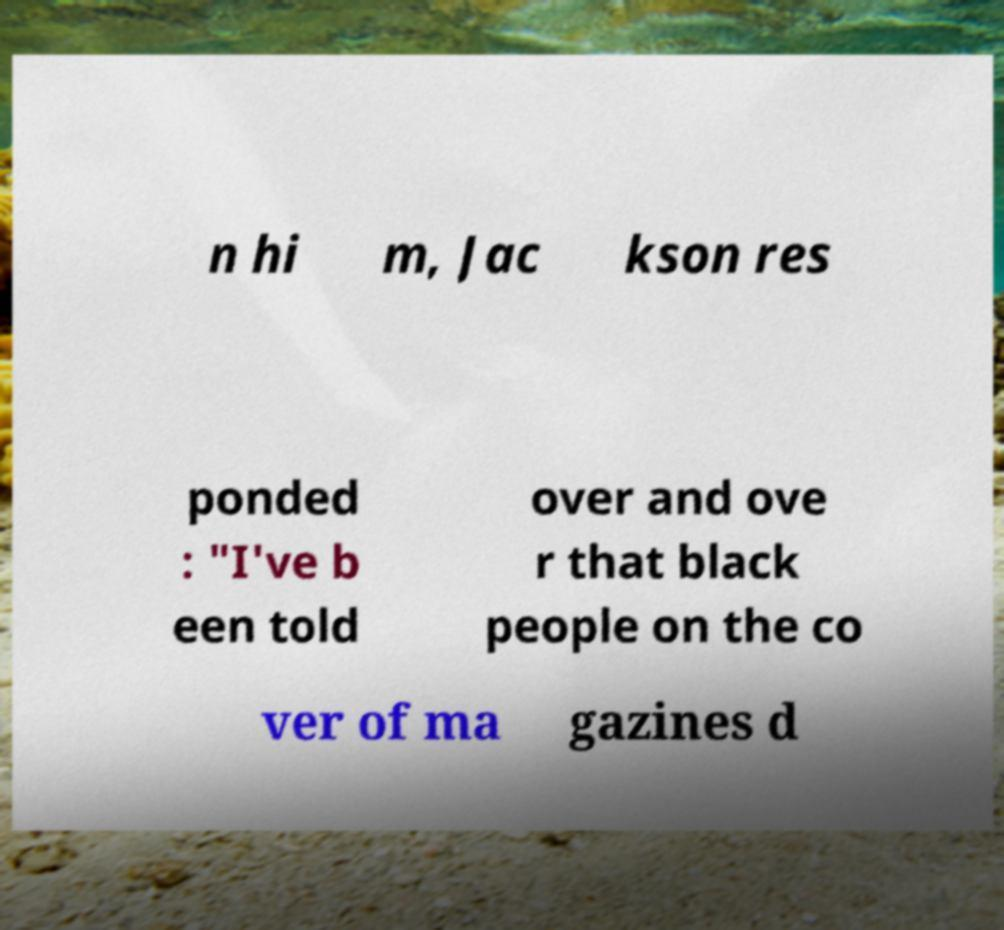What messages or text are displayed in this image? I need them in a readable, typed format. n hi m, Jac kson res ponded : "I've b een told over and ove r that black people on the co ver of ma gazines d 